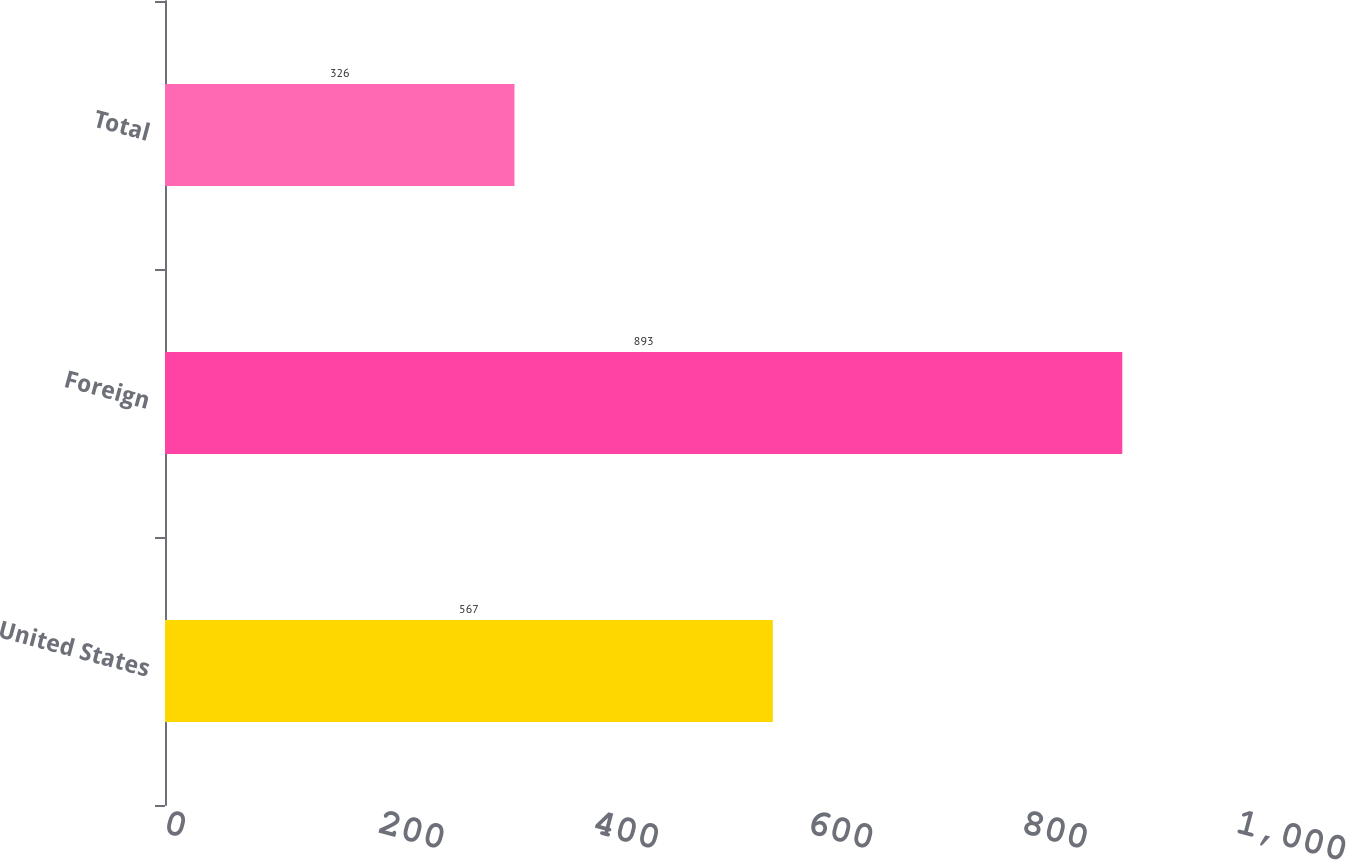Convert chart. <chart><loc_0><loc_0><loc_500><loc_500><bar_chart><fcel>United States<fcel>Foreign<fcel>Total<nl><fcel>567<fcel>893<fcel>326<nl></chart> 